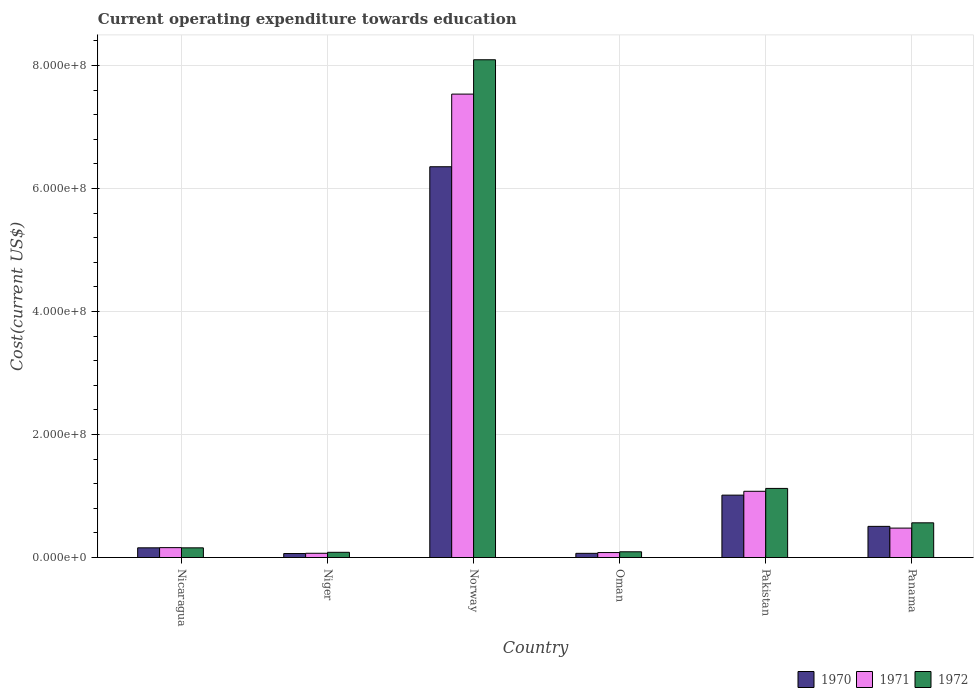How many different coloured bars are there?
Offer a terse response. 3. How many bars are there on the 5th tick from the right?
Offer a very short reply. 3. What is the label of the 2nd group of bars from the left?
Offer a very short reply. Niger. In how many cases, is the number of bars for a given country not equal to the number of legend labels?
Your response must be concise. 0. What is the expenditure towards education in 1970 in Pakistan?
Make the answer very short. 1.01e+08. Across all countries, what is the maximum expenditure towards education in 1970?
Ensure brevity in your answer.  6.35e+08. Across all countries, what is the minimum expenditure towards education in 1970?
Keep it short and to the point. 6.48e+06. In which country was the expenditure towards education in 1971 maximum?
Provide a succinct answer. Norway. In which country was the expenditure towards education in 1972 minimum?
Make the answer very short. Niger. What is the total expenditure towards education in 1972 in the graph?
Offer a very short reply. 1.01e+09. What is the difference between the expenditure towards education in 1970 in Oman and that in Panama?
Offer a very short reply. -4.38e+07. What is the difference between the expenditure towards education in 1971 in Niger and the expenditure towards education in 1970 in Panama?
Your response must be concise. -4.37e+07. What is the average expenditure towards education in 1971 per country?
Make the answer very short. 1.57e+08. What is the difference between the expenditure towards education of/in 1971 and expenditure towards education of/in 1970 in Oman?
Give a very brief answer. 1.29e+06. What is the ratio of the expenditure towards education in 1971 in Norway to that in Oman?
Offer a terse response. 93.09. What is the difference between the highest and the second highest expenditure towards education in 1972?
Ensure brevity in your answer.  -7.53e+08. What is the difference between the highest and the lowest expenditure towards education in 1970?
Your answer should be very brief. 6.29e+08. In how many countries, is the expenditure towards education in 1972 greater than the average expenditure towards education in 1972 taken over all countries?
Provide a succinct answer. 1. Is the sum of the expenditure towards education in 1972 in Niger and Norway greater than the maximum expenditure towards education in 1971 across all countries?
Your answer should be compact. Yes. What does the 2nd bar from the right in Norway represents?
Offer a very short reply. 1971. How many bars are there?
Give a very brief answer. 18. How many countries are there in the graph?
Offer a terse response. 6. Are the values on the major ticks of Y-axis written in scientific E-notation?
Your response must be concise. Yes. Does the graph contain any zero values?
Ensure brevity in your answer.  No. Where does the legend appear in the graph?
Provide a short and direct response. Bottom right. How many legend labels are there?
Offer a very short reply. 3. How are the legend labels stacked?
Keep it short and to the point. Horizontal. What is the title of the graph?
Provide a succinct answer. Current operating expenditure towards education. Does "1973" appear as one of the legend labels in the graph?
Your answer should be compact. No. What is the label or title of the Y-axis?
Give a very brief answer. Cost(current US$). What is the Cost(current US$) in 1970 in Nicaragua?
Your answer should be very brief. 1.58e+07. What is the Cost(current US$) in 1971 in Nicaragua?
Provide a short and direct response. 1.61e+07. What is the Cost(current US$) in 1972 in Nicaragua?
Offer a very short reply. 1.57e+07. What is the Cost(current US$) of 1970 in Niger?
Provide a succinct answer. 6.48e+06. What is the Cost(current US$) of 1971 in Niger?
Provide a succinct answer. 6.92e+06. What is the Cost(current US$) in 1972 in Niger?
Your answer should be very brief. 8.50e+06. What is the Cost(current US$) in 1970 in Norway?
Offer a very short reply. 6.35e+08. What is the Cost(current US$) in 1971 in Norway?
Provide a succinct answer. 7.53e+08. What is the Cost(current US$) of 1972 in Norway?
Provide a short and direct response. 8.09e+08. What is the Cost(current US$) of 1970 in Oman?
Your response must be concise. 6.80e+06. What is the Cost(current US$) in 1971 in Oman?
Your response must be concise. 8.09e+06. What is the Cost(current US$) in 1972 in Oman?
Give a very brief answer. 9.32e+06. What is the Cost(current US$) in 1970 in Pakistan?
Provide a short and direct response. 1.01e+08. What is the Cost(current US$) in 1971 in Pakistan?
Keep it short and to the point. 1.08e+08. What is the Cost(current US$) in 1972 in Pakistan?
Your answer should be compact. 1.12e+08. What is the Cost(current US$) in 1970 in Panama?
Provide a short and direct response. 5.07e+07. What is the Cost(current US$) of 1971 in Panama?
Offer a very short reply. 4.78e+07. What is the Cost(current US$) of 1972 in Panama?
Ensure brevity in your answer.  5.64e+07. Across all countries, what is the maximum Cost(current US$) of 1970?
Your answer should be very brief. 6.35e+08. Across all countries, what is the maximum Cost(current US$) in 1971?
Provide a short and direct response. 7.53e+08. Across all countries, what is the maximum Cost(current US$) of 1972?
Give a very brief answer. 8.09e+08. Across all countries, what is the minimum Cost(current US$) in 1970?
Your answer should be very brief. 6.48e+06. Across all countries, what is the minimum Cost(current US$) in 1971?
Your answer should be compact. 6.92e+06. Across all countries, what is the minimum Cost(current US$) in 1972?
Make the answer very short. 8.50e+06. What is the total Cost(current US$) of 1970 in the graph?
Give a very brief answer. 8.16e+08. What is the total Cost(current US$) of 1971 in the graph?
Keep it short and to the point. 9.40e+08. What is the total Cost(current US$) in 1972 in the graph?
Keep it short and to the point. 1.01e+09. What is the difference between the Cost(current US$) in 1970 in Nicaragua and that in Niger?
Provide a short and direct response. 9.29e+06. What is the difference between the Cost(current US$) in 1971 in Nicaragua and that in Niger?
Provide a succinct answer. 9.15e+06. What is the difference between the Cost(current US$) of 1972 in Nicaragua and that in Niger?
Your response must be concise. 7.25e+06. What is the difference between the Cost(current US$) in 1970 in Nicaragua and that in Norway?
Your answer should be very brief. -6.19e+08. What is the difference between the Cost(current US$) in 1971 in Nicaragua and that in Norway?
Offer a very short reply. -7.37e+08. What is the difference between the Cost(current US$) of 1972 in Nicaragua and that in Norway?
Your answer should be very brief. -7.93e+08. What is the difference between the Cost(current US$) of 1970 in Nicaragua and that in Oman?
Provide a short and direct response. 8.97e+06. What is the difference between the Cost(current US$) of 1971 in Nicaragua and that in Oman?
Provide a succinct answer. 7.98e+06. What is the difference between the Cost(current US$) of 1972 in Nicaragua and that in Oman?
Offer a terse response. 6.42e+06. What is the difference between the Cost(current US$) of 1970 in Nicaragua and that in Pakistan?
Offer a terse response. -8.57e+07. What is the difference between the Cost(current US$) in 1971 in Nicaragua and that in Pakistan?
Your answer should be very brief. -9.16e+07. What is the difference between the Cost(current US$) in 1972 in Nicaragua and that in Pakistan?
Provide a succinct answer. -9.66e+07. What is the difference between the Cost(current US$) in 1970 in Nicaragua and that in Panama?
Give a very brief answer. -3.49e+07. What is the difference between the Cost(current US$) of 1971 in Nicaragua and that in Panama?
Offer a very short reply. -3.17e+07. What is the difference between the Cost(current US$) of 1972 in Nicaragua and that in Panama?
Make the answer very short. -4.07e+07. What is the difference between the Cost(current US$) of 1970 in Niger and that in Norway?
Offer a very short reply. -6.29e+08. What is the difference between the Cost(current US$) of 1971 in Niger and that in Norway?
Ensure brevity in your answer.  -7.46e+08. What is the difference between the Cost(current US$) of 1972 in Niger and that in Norway?
Provide a short and direct response. -8.01e+08. What is the difference between the Cost(current US$) in 1970 in Niger and that in Oman?
Your answer should be very brief. -3.20e+05. What is the difference between the Cost(current US$) of 1971 in Niger and that in Oman?
Keep it short and to the point. -1.17e+06. What is the difference between the Cost(current US$) in 1972 in Niger and that in Oman?
Keep it short and to the point. -8.26e+05. What is the difference between the Cost(current US$) of 1970 in Niger and that in Pakistan?
Your answer should be very brief. -9.49e+07. What is the difference between the Cost(current US$) in 1971 in Niger and that in Pakistan?
Make the answer very short. -1.01e+08. What is the difference between the Cost(current US$) of 1972 in Niger and that in Pakistan?
Provide a succinct answer. -1.04e+08. What is the difference between the Cost(current US$) in 1970 in Niger and that in Panama?
Offer a very short reply. -4.42e+07. What is the difference between the Cost(current US$) in 1971 in Niger and that in Panama?
Your response must be concise. -4.09e+07. What is the difference between the Cost(current US$) in 1972 in Niger and that in Panama?
Offer a terse response. -4.79e+07. What is the difference between the Cost(current US$) in 1970 in Norway and that in Oman?
Offer a very short reply. 6.28e+08. What is the difference between the Cost(current US$) in 1971 in Norway and that in Oman?
Provide a succinct answer. 7.45e+08. What is the difference between the Cost(current US$) in 1972 in Norway and that in Oman?
Your answer should be compact. 8.00e+08. What is the difference between the Cost(current US$) of 1970 in Norway and that in Pakistan?
Your response must be concise. 5.34e+08. What is the difference between the Cost(current US$) in 1971 in Norway and that in Pakistan?
Provide a short and direct response. 6.46e+08. What is the difference between the Cost(current US$) in 1972 in Norway and that in Pakistan?
Your answer should be very brief. 6.97e+08. What is the difference between the Cost(current US$) in 1970 in Norway and that in Panama?
Ensure brevity in your answer.  5.85e+08. What is the difference between the Cost(current US$) in 1971 in Norway and that in Panama?
Make the answer very short. 7.06e+08. What is the difference between the Cost(current US$) in 1972 in Norway and that in Panama?
Offer a very short reply. 7.53e+08. What is the difference between the Cost(current US$) of 1970 in Oman and that in Pakistan?
Make the answer very short. -9.46e+07. What is the difference between the Cost(current US$) of 1971 in Oman and that in Pakistan?
Keep it short and to the point. -9.96e+07. What is the difference between the Cost(current US$) in 1972 in Oman and that in Pakistan?
Your answer should be very brief. -1.03e+08. What is the difference between the Cost(current US$) of 1970 in Oman and that in Panama?
Offer a terse response. -4.38e+07. What is the difference between the Cost(current US$) of 1971 in Oman and that in Panama?
Provide a succinct answer. -3.97e+07. What is the difference between the Cost(current US$) in 1972 in Oman and that in Panama?
Provide a short and direct response. -4.71e+07. What is the difference between the Cost(current US$) of 1970 in Pakistan and that in Panama?
Keep it short and to the point. 5.08e+07. What is the difference between the Cost(current US$) in 1971 in Pakistan and that in Panama?
Provide a succinct answer. 5.98e+07. What is the difference between the Cost(current US$) of 1972 in Pakistan and that in Panama?
Your answer should be very brief. 5.59e+07. What is the difference between the Cost(current US$) of 1970 in Nicaragua and the Cost(current US$) of 1971 in Niger?
Your answer should be compact. 8.85e+06. What is the difference between the Cost(current US$) of 1970 in Nicaragua and the Cost(current US$) of 1972 in Niger?
Your answer should be very brief. 7.28e+06. What is the difference between the Cost(current US$) of 1971 in Nicaragua and the Cost(current US$) of 1972 in Niger?
Provide a short and direct response. 7.58e+06. What is the difference between the Cost(current US$) of 1970 in Nicaragua and the Cost(current US$) of 1971 in Norway?
Your answer should be compact. -7.38e+08. What is the difference between the Cost(current US$) in 1970 in Nicaragua and the Cost(current US$) in 1972 in Norway?
Provide a succinct answer. -7.93e+08. What is the difference between the Cost(current US$) of 1971 in Nicaragua and the Cost(current US$) of 1972 in Norway?
Offer a terse response. -7.93e+08. What is the difference between the Cost(current US$) of 1970 in Nicaragua and the Cost(current US$) of 1971 in Oman?
Provide a short and direct response. 7.68e+06. What is the difference between the Cost(current US$) of 1970 in Nicaragua and the Cost(current US$) of 1972 in Oman?
Ensure brevity in your answer.  6.45e+06. What is the difference between the Cost(current US$) in 1971 in Nicaragua and the Cost(current US$) in 1972 in Oman?
Offer a terse response. 6.75e+06. What is the difference between the Cost(current US$) of 1970 in Nicaragua and the Cost(current US$) of 1971 in Pakistan?
Your answer should be very brief. -9.19e+07. What is the difference between the Cost(current US$) of 1970 in Nicaragua and the Cost(current US$) of 1972 in Pakistan?
Ensure brevity in your answer.  -9.66e+07. What is the difference between the Cost(current US$) of 1971 in Nicaragua and the Cost(current US$) of 1972 in Pakistan?
Your answer should be compact. -9.63e+07. What is the difference between the Cost(current US$) in 1970 in Nicaragua and the Cost(current US$) in 1971 in Panama?
Offer a terse response. -3.20e+07. What is the difference between the Cost(current US$) in 1970 in Nicaragua and the Cost(current US$) in 1972 in Panama?
Offer a terse response. -4.06e+07. What is the difference between the Cost(current US$) in 1971 in Nicaragua and the Cost(current US$) in 1972 in Panama?
Offer a very short reply. -4.03e+07. What is the difference between the Cost(current US$) in 1970 in Niger and the Cost(current US$) in 1971 in Norway?
Your answer should be very brief. -7.47e+08. What is the difference between the Cost(current US$) in 1970 in Niger and the Cost(current US$) in 1972 in Norway?
Ensure brevity in your answer.  -8.03e+08. What is the difference between the Cost(current US$) in 1971 in Niger and the Cost(current US$) in 1972 in Norway?
Ensure brevity in your answer.  -8.02e+08. What is the difference between the Cost(current US$) in 1970 in Niger and the Cost(current US$) in 1971 in Oman?
Offer a terse response. -1.61e+06. What is the difference between the Cost(current US$) in 1970 in Niger and the Cost(current US$) in 1972 in Oman?
Make the answer very short. -2.84e+06. What is the difference between the Cost(current US$) of 1971 in Niger and the Cost(current US$) of 1972 in Oman?
Your answer should be compact. -2.40e+06. What is the difference between the Cost(current US$) in 1970 in Niger and the Cost(current US$) in 1971 in Pakistan?
Your response must be concise. -1.01e+08. What is the difference between the Cost(current US$) of 1970 in Niger and the Cost(current US$) of 1972 in Pakistan?
Give a very brief answer. -1.06e+08. What is the difference between the Cost(current US$) in 1971 in Niger and the Cost(current US$) in 1972 in Pakistan?
Your answer should be compact. -1.05e+08. What is the difference between the Cost(current US$) of 1970 in Niger and the Cost(current US$) of 1971 in Panama?
Offer a terse response. -4.13e+07. What is the difference between the Cost(current US$) of 1970 in Niger and the Cost(current US$) of 1972 in Panama?
Keep it short and to the point. -4.99e+07. What is the difference between the Cost(current US$) of 1971 in Niger and the Cost(current US$) of 1972 in Panama?
Provide a short and direct response. -4.95e+07. What is the difference between the Cost(current US$) in 1970 in Norway and the Cost(current US$) in 1971 in Oman?
Your response must be concise. 6.27e+08. What is the difference between the Cost(current US$) in 1970 in Norway and the Cost(current US$) in 1972 in Oman?
Offer a terse response. 6.26e+08. What is the difference between the Cost(current US$) in 1971 in Norway and the Cost(current US$) in 1972 in Oman?
Make the answer very short. 7.44e+08. What is the difference between the Cost(current US$) in 1970 in Norway and the Cost(current US$) in 1971 in Pakistan?
Keep it short and to the point. 5.28e+08. What is the difference between the Cost(current US$) of 1970 in Norway and the Cost(current US$) of 1972 in Pakistan?
Make the answer very short. 5.23e+08. What is the difference between the Cost(current US$) of 1971 in Norway and the Cost(current US$) of 1972 in Pakistan?
Offer a terse response. 6.41e+08. What is the difference between the Cost(current US$) in 1970 in Norway and the Cost(current US$) in 1971 in Panama?
Your response must be concise. 5.87e+08. What is the difference between the Cost(current US$) in 1970 in Norway and the Cost(current US$) in 1972 in Panama?
Provide a short and direct response. 5.79e+08. What is the difference between the Cost(current US$) in 1971 in Norway and the Cost(current US$) in 1972 in Panama?
Your answer should be compact. 6.97e+08. What is the difference between the Cost(current US$) of 1970 in Oman and the Cost(current US$) of 1971 in Pakistan?
Your answer should be very brief. -1.01e+08. What is the difference between the Cost(current US$) in 1970 in Oman and the Cost(current US$) in 1972 in Pakistan?
Offer a terse response. -1.06e+08. What is the difference between the Cost(current US$) in 1971 in Oman and the Cost(current US$) in 1972 in Pakistan?
Give a very brief answer. -1.04e+08. What is the difference between the Cost(current US$) of 1970 in Oman and the Cost(current US$) of 1971 in Panama?
Ensure brevity in your answer.  -4.10e+07. What is the difference between the Cost(current US$) of 1970 in Oman and the Cost(current US$) of 1972 in Panama?
Give a very brief answer. -4.96e+07. What is the difference between the Cost(current US$) in 1971 in Oman and the Cost(current US$) in 1972 in Panama?
Your answer should be compact. -4.83e+07. What is the difference between the Cost(current US$) of 1970 in Pakistan and the Cost(current US$) of 1971 in Panama?
Offer a terse response. 5.36e+07. What is the difference between the Cost(current US$) in 1970 in Pakistan and the Cost(current US$) in 1972 in Panama?
Provide a succinct answer. 4.50e+07. What is the difference between the Cost(current US$) of 1971 in Pakistan and the Cost(current US$) of 1972 in Panama?
Offer a very short reply. 5.12e+07. What is the average Cost(current US$) in 1970 per country?
Provide a succinct answer. 1.36e+08. What is the average Cost(current US$) of 1971 per country?
Ensure brevity in your answer.  1.57e+08. What is the average Cost(current US$) of 1972 per country?
Ensure brevity in your answer.  1.69e+08. What is the difference between the Cost(current US$) in 1970 and Cost(current US$) in 1971 in Nicaragua?
Provide a succinct answer. -3.03e+05. What is the difference between the Cost(current US$) of 1970 and Cost(current US$) of 1972 in Nicaragua?
Make the answer very short. 3.08e+04. What is the difference between the Cost(current US$) of 1971 and Cost(current US$) of 1972 in Nicaragua?
Ensure brevity in your answer.  3.34e+05. What is the difference between the Cost(current US$) in 1970 and Cost(current US$) in 1971 in Niger?
Ensure brevity in your answer.  -4.39e+05. What is the difference between the Cost(current US$) in 1970 and Cost(current US$) in 1972 in Niger?
Your answer should be very brief. -2.01e+06. What is the difference between the Cost(current US$) of 1971 and Cost(current US$) of 1972 in Niger?
Your answer should be very brief. -1.57e+06. What is the difference between the Cost(current US$) in 1970 and Cost(current US$) in 1971 in Norway?
Provide a short and direct response. -1.18e+08. What is the difference between the Cost(current US$) in 1970 and Cost(current US$) in 1972 in Norway?
Give a very brief answer. -1.74e+08. What is the difference between the Cost(current US$) in 1971 and Cost(current US$) in 1972 in Norway?
Offer a very short reply. -5.58e+07. What is the difference between the Cost(current US$) of 1970 and Cost(current US$) of 1971 in Oman?
Make the answer very short. -1.29e+06. What is the difference between the Cost(current US$) in 1970 and Cost(current US$) in 1972 in Oman?
Ensure brevity in your answer.  -2.52e+06. What is the difference between the Cost(current US$) of 1971 and Cost(current US$) of 1972 in Oman?
Make the answer very short. -1.23e+06. What is the difference between the Cost(current US$) of 1970 and Cost(current US$) of 1971 in Pakistan?
Keep it short and to the point. -6.25e+06. What is the difference between the Cost(current US$) in 1970 and Cost(current US$) in 1972 in Pakistan?
Provide a short and direct response. -1.09e+07. What is the difference between the Cost(current US$) of 1971 and Cost(current US$) of 1972 in Pakistan?
Provide a short and direct response. -4.68e+06. What is the difference between the Cost(current US$) of 1970 and Cost(current US$) of 1971 in Panama?
Offer a very short reply. 2.83e+06. What is the difference between the Cost(current US$) in 1970 and Cost(current US$) in 1972 in Panama?
Provide a short and direct response. -5.77e+06. What is the difference between the Cost(current US$) of 1971 and Cost(current US$) of 1972 in Panama?
Provide a short and direct response. -8.60e+06. What is the ratio of the Cost(current US$) of 1970 in Nicaragua to that in Niger?
Your answer should be compact. 2.43. What is the ratio of the Cost(current US$) of 1971 in Nicaragua to that in Niger?
Offer a terse response. 2.32. What is the ratio of the Cost(current US$) in 1972 in Nicaragua to that in Niger?
Give a very brief answer. 1.85. What is the ratio of the Cost(current US$) in 1970 in Nicaragua to that in Norway?
Offer a terse response. 0.02. What is the ratio of the Cost(current US$) of 1971 in Nicaragua to that in Norway?
Offer a terse response. 0.02. What is the ratio of the Cost(current US$) in 1972 in Nicaragua to that in Norway?
Offer a very short reply. 0.02. What is the ratio of the Cost(current US$) in 1970 in Nicaragua to that in Oman?
Your answer should be compact. 2.32. What is the ratio of the Cost(current US$) in 1971 in Nicaragua to that in Oman?
Your answer should be very brief. 1.99. What is the ratio of the Cost(current US$) in 1972 in Nicaragua to that in Oman?
Your response must be concise. 1.69. What is the ratio of the Cost(current US$) in 1970 in Nicaragua to that in Pakistan?
Provide a short and direct response. 0.16. What is the ratio of the Cost(current US$) in 1971 in Nicaragua to that in Pakistan?
Your answer should be compact. 0.15. What is the ratio of the Cost(current US$) in 1972 in Nicaragua to that in Pakistan?
Your response must be concise. 0.14. What is the ratio of the Cost(current US$) of 1970 in Nicaragua to that in Panama?
Your answer should be compact. 0.31. What is the ratio of the Cost(current US$) in 1971 in Nicaragua to that in Panama?
Ensure brevity in your answer.  0.34. What is the ratio of the Cost(current US$) in 1972 in Nicaragua to that in Panama?
Keep it short and to the point. 0.28. What is the ratio of the Cost(current US$) in 1970 in Niger to that in Norway?
Provide a short and direct response. 0.01. What is the ratio of the Cost(current US$) in 1971 in Niger to that in Norway?
Offer a terse response. 0.01. What is the ratio of the Cost(current US$) of 1972 in Niger to that in Norway?
Keep it short and to the point. 0.01. What is the ratio of the Cost(current US$) of 1970 in Niger to that in Oman?
Make the answer very short. 0.95. What is the ratio of the Cost(current US$) of 1971 in Niger to that in Oman?
Make the answer very short. 0.86. What is the ratio of the Cost(current US$) of 1972 in Niger to that in Oman?
Give a very brief answer. 0.91. What is the ratio of the Cost(current US$) of 1970 in Niger to that in Pakistan?
Your answer should be compact. 0.06. What is the ratio of the Cost(current US$) in 1971 in Niger to that in Pakistan?
Your answer should be compact. 0.06. What is the ratio of the Cost(current US$) of 1972 in Niger to that in Pakistan?
Ensure brevity in your answer.  0.08. What is the ratio of the Cost(current US$) of 1970 in Niger to that in Panama?
Make the answer very short. 0.13. What is the ratio of the Cost(current US$) of 1971 in Niger to that in Panama?
Your response must be concise. 0.14. What is the ratio of the Cost(current US$) of 1972 in Niger to that in Panama?
Your answer should be compact. 0.15. What is the ratio of the Cost(current US$) of 1970 in Norway to that in Oman?
Provide a succinct answer. 93.36. What is the ratio of the Cost(current US$) of 1971 in Norway to that in Oman?
Offer a very short reply. 93.09. What is the ratio of the Cost(current US$) in 1972 in Norway to that in Oman?
Your answer should be very brief. 86.8. What is the ratio of the Cost(current US$) in 1970 in Norway to that in Pakistan?
Ensure brevity in your answer.  6.26. What is the ratio of the Cost(current US$) of 1971 in Norway to that in Pakistan?
Keep it short and to the point. 7. What is the ratio of the Cost(current US$) of 1972 in Norway to that in Pakistan?
Keep it short and to the point. 7.2. What is the ratio of the Cost(current US$) of 1970 in Norway to that in Panama?
Make the answer very short. 12.54. What is the ratio of the Cost(current US$) in 1971 in Norway to that in Panama?
Your answer should be very brief. 15.75. What is the ratio of the Cost(current US$) of 1972 in Norway to that in Panama?
Keep it short and to the point. 14.34. What is the ratio of the Cost(current US$) of 1970 in Oman to that in Pakistan?
Give a very brief answer. 0.07. What is the ratio of the Cost(current US$) of 1971 in Oman to that in Pakistan?
Give a very brief answer. 0.08. What is the ratio of the Cost(current US$) in 1972 in Oman to that in Pakistan?
Offer a terse response. 0.08. What is the ratio of the Cost(current US$) in 1970 in Oman to that in Panama?
Offer a terse response. 0.13. What is the ratio of the Cost(current US$) of 1971 in Oman to that in Panama?
Keep it short and to the point. 0.17. What is the ratio of the Cost(current US$) of 1972 in Oman to that in Panama?
Provide a succinct answer. 0.17. What is the ratio of the Cost(current US$) in 1970 in Pakistan to that in Panama?
Offer a terse response. 2. What is the ratio of the Cost(current US$) of 1971 in Pakistan to that in Panama?
Provide a short and direct response. 2.25. What is the ratio of the Cost(current US$) in 1972 in Pakistan to that in Panama?
Make the answer very short. 1.99. What is the difference between the highest and the second highest Cost(current US$) of 1970?
Your answer should be very brief. 5.34e+08. What is the difference between the highest and the second highest Cost(current US$) of 1971?
Make the answer very short. 6.46e+08. What is the difference between the highest and the second highest Cost(current US$) in 1972?
Offer a terse response. 6.97e+08. What is the difference between the highest and the lowest Cost(current US$) in 1970?
Provide a succinct answer. 6.29e+08. What is the difference between the highest and the lowest Cost(current US$) in 1971?
Offer a very short reply. 7.46e+08. What is the difference between the highest and the lowest Cost(current US$) of 1972?
Ensure brevity in your answer.  8.01e+08. 